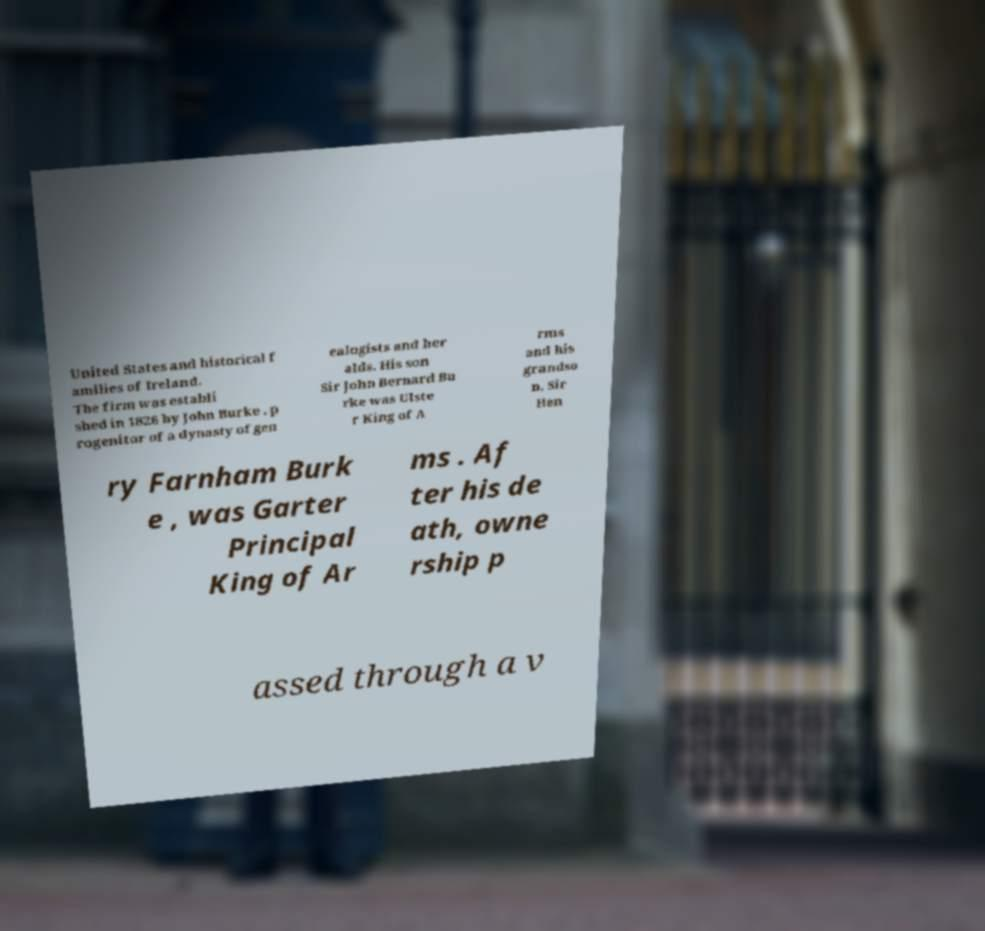Can you accurately transcribe the text from the provided image for me? United States and historical f amilies of Ireland. The firm was establi shed in 1826 by John Burke , p rogenitor of a dynasty of gen ealogists and her alds. His son Sir John Bernard Bu rke was Ulste r King of A rms and his grandso n, Sir Hen ry Farnham Burk e , was Garter Principal King of Ar ms . Af ter his de ath, owne rship p assed through a v 